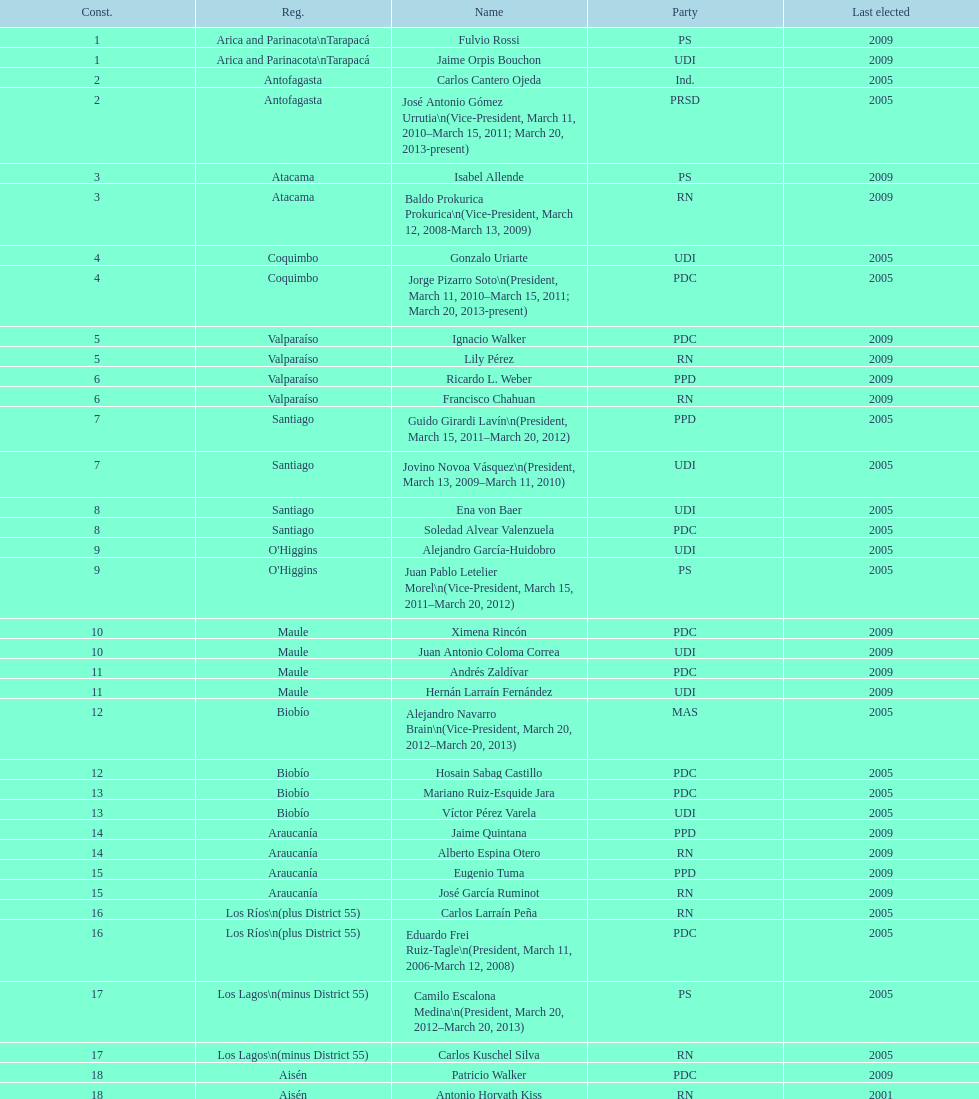What is the total number of constituencies? 19. Help me parse the entirety of this table. {'header': ['Const.', 'Reg.', 'Name', 'Party', 'Last elected'], 'rows': [['1', 'Arica and Parinacota\\nTarapacá', 'Fulvio Rossi', 'PS', '2009'], ['1', 'Arica and Parinacota\\nTarapacá', 'Jaime Orpis Bouchon', 'UDI', '2009'], ['2', 'Antofagasta', 'Carlos Cantero Ojeda', 'Ind.', '2005'], ['2', 'Antofagasta', 'José Antonio Gómez Urrutia\\n(Vice-President, March 11, 2010–March 15, 2011; March 20, 2013-present)', 'PRSD', '2005'], ['3', 'Atacama', 'Isabel Allende', 'PS', '2009'], ['3', 'Atacama', 'Baldo Prokurica Prokurica\\n(Vice-President, March 12, 2008-March 13, 2009)', 'RN', '2009'], ['4', 'Coquimbo', 'Gonzalo Uriarte', 'UDI', '2005'], ['4', 'Coquimbo', 'Jorge Pizarro Soto\\n(President, March 11, 2010–March 15, 2011; March 20, 2013-present)', 'PDC', '2005'], ['5', 'Valparaíso', 'Ignacio Walker', 'PDC', '2009'], ['5', 'Valparaíso', 'Lily Pérez', 'RN', '2009'], ['6', 'Valparaíso', 'Ricardo L. Weber', 'PPD', '2009'], ['6', 'Valparaíso', 'Francisco Chahuan', 'RN', '2009'], ['7', 'Santiago', 'Guido Girardi Lavín\\n(President, March 15, 2011–March 20, 2012)', 'PPD', '2005'], ['7', 'Santiago', 'Jovino Novoa Vásquez\\n(President, March 13, 2009–March 11, 2010)', 'UDI', '2005'], ['8', 'Santiago', 'Ena von Baer', 'UDI', '2005'], ['8', 'Santiago', 'Soledad Alvear Valenzuela', 'PDC', '2005'], ['9', "O'Higgins", 'Alejandro García-Huidobro', 'UDI', '2005'], ['9', "O'Higgins", 'Juan Pablo Letelier Morel\\n(Vice-President, March 15, 2011–March 20, 2012)', 'PS', '2005'], ['10', 'Maule', 'Ximena Rincón', 'PDC', '2009'], ['10', 'Maule', 'Juan Antonio Coloma Correa', 'UDI', '2009'], ['11', 'Maule', 'Andrés Zaldívar', 'PDC', '2009'], ['11', 'Maule', 'Hernán Larraín Fernández', 'UDI', '2009'], ['12', 'Biobío', 'Alejandro Navarro Brain\\n(Vice-President, March 20, 2012–March 20, 2013)', 'MAS', '2005'], ['12', 'Biobío', 'Hosain Sabag Castillo', 'PDC', '2005'], ['13', 'Biobío', 'Mariano Ruiz-Esquide Jara', 'PDC', '2005'], ['13', 'Biobío', 'Víctor Pérez Varela', 'UDI', '2005'], ['14', 'Araucanía', 'Jaime Quintana', 'PPD', '2009'], ['14', 'Araucanía', 'Alberto Espina Otero', 'RN', '2009'], ['15', 'Araucanía', 'Eugenio Tuma', 'PPD', '2009'], ['15', 'Araucanía', 'José García Ruminot', 'RN', '2009'], ['16', 'Los Ríos\\n(plus District 55)', 'Carlos Larraín Peña', 'RN', '2005'], ['16', 'Los Ríos\\n(plus District 55)', 'Eduardo Frei Ruiz-Tagle\\n(President, March 11, 2006-March 12, 2008)', 'PDC', '2005'], ['17', 'Los Lagos\\n(minus District 55)', 'Camilo Escalona Medina\\n(President, March 20, 2012–March 20, 2013)', 'PS', '2005'], ['17', 'Los Lagos\\n(minus District 55)', 'Carlos Kuschel Silva', 'RN', '2005'], ['18', 'Aisén', 'Patricio Walker', 'PDC', '2009'], ['18', 'Aisén', 'Antonio Horvath Kiss', 'RN', '2001'], ['19', 'Magallanes', 'Carlos Bianchi Chelech\\n(Vice-President, March 13, 2009–March 11, 2010)', 'Ind.', '2005'], ['19', 'Magallanes', 'Pedro Muñoz Aburto', 'PS', '2005']]} 